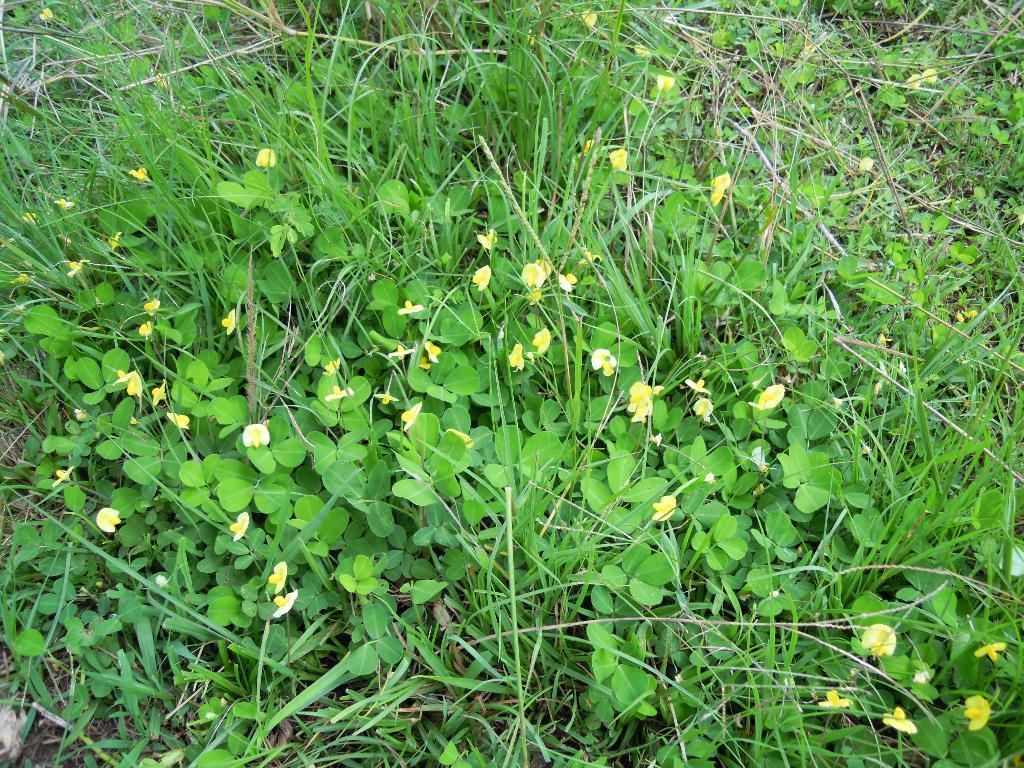What type of living organisms can be seen in the image? Plants can be seen in the image. What type of vegetation is present on the ground in the image? There is grass on the ground in the image. What type of prose is being written by the plants in the image? There are no plants writing prose in the image, as plants do not have the ability to write. 